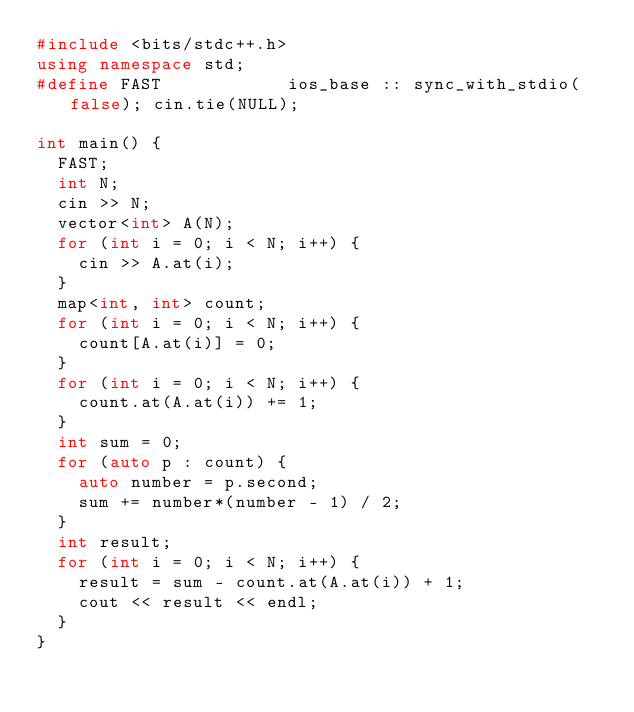Convert code to text. <code><loc_0><loc_0><loc_500><loc_500><_C++_>#include <bits/stdc++.h>
using namespace std;
#define FAST       			ios_base :: sync_with_stdio(false); cin.tie(NULL);

int main() {
  FAST;
  int N;
  cin >> N;
  vector<int> A(N);
  for (int i = 0; i < N; i++) {
    cin >> A.at(i);
  }
  map<int, int> count;
  for (int i = 0; i < N; i++) {
    count[A.at(i)] = 0;
  }
  for (int i = 0; i < N; i++) {
    count.at(A.at(i)) += 1;
  }
  int sum = 0;
  for (auto p : count) {
    auto number = p.second;
    sum += number*(number - 1) / 2;
  }
  int result;
  for (int i = 0; i < N; i++) {
    result = sum - count.at(A.at(i)) + 1;
    cout << result << endl;
  }
}</code> 